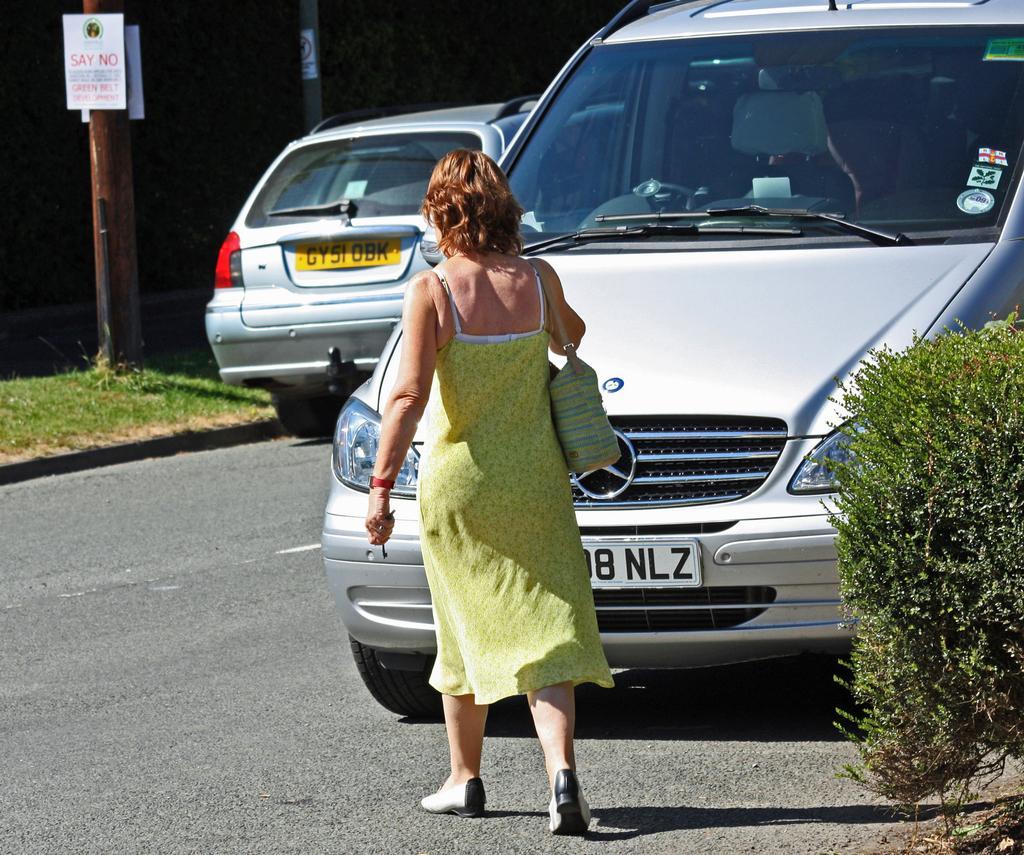Could you give a brief overview of what you see in this image? In this picture there is a woman who is wearing green dress, bag, band and shoe. Beside her we can see a car. On the left there is another car which is parked near to the pole. On the top we can see posters. On the right there is a plant. Here we can see grass. 